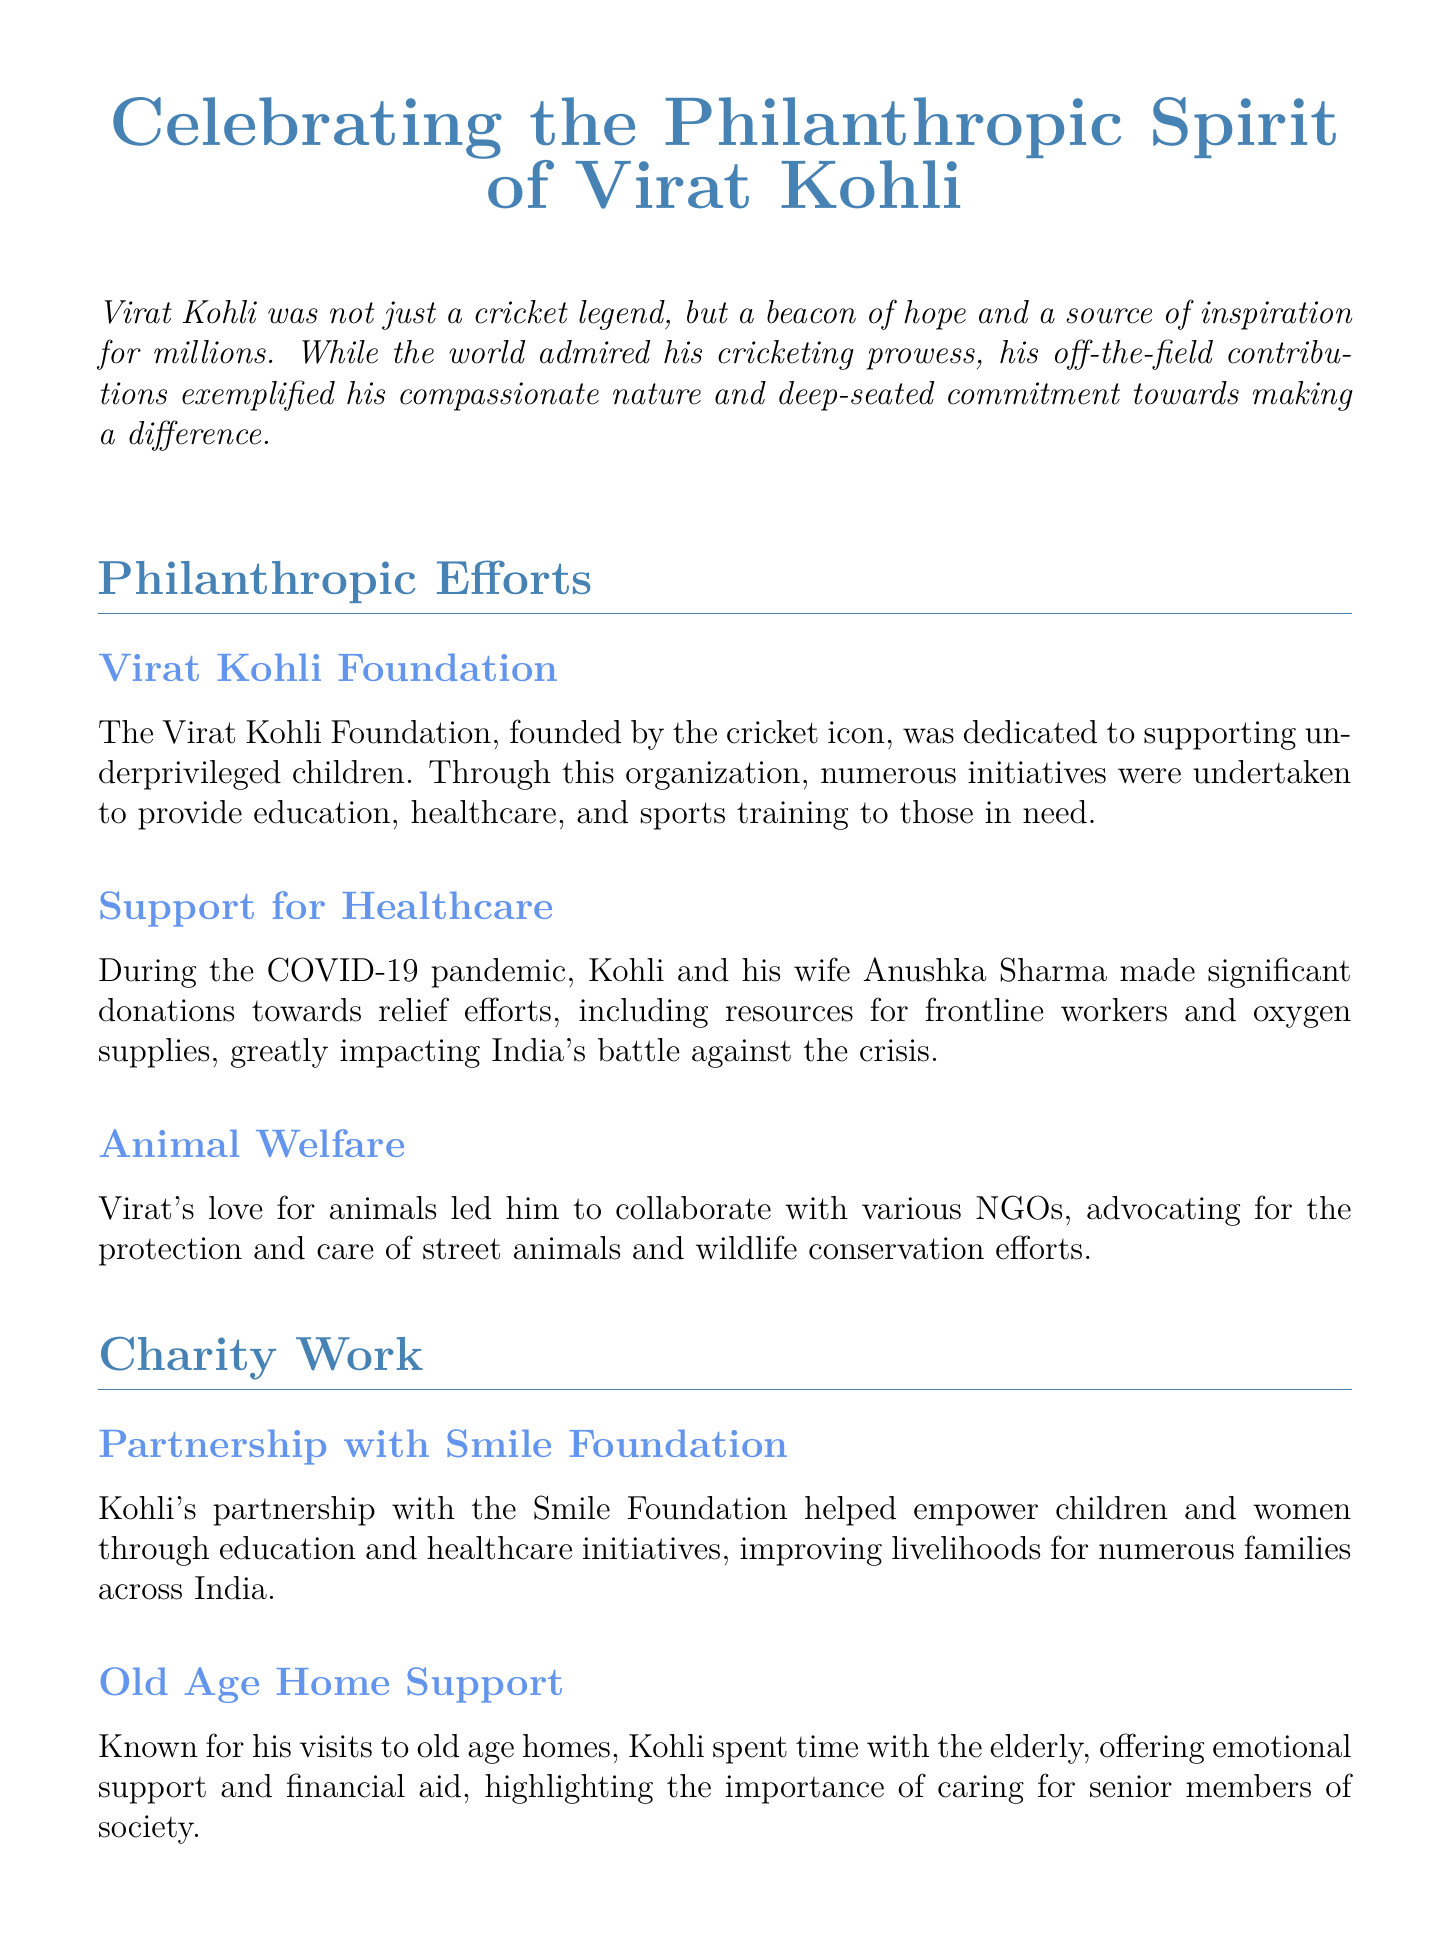What is the name of Virat Kohli's foundation? The document mentions the Virat Kohli Foundation as his philanthropic initiative.
Answer: Virat Kohli Foundation What type of support did Kohli and Anushka provide during the COVID-19 pandemic? They made significant donations towards relief efforts, including resources for frontline workers and oxygen supplies.
Answer: Relief efforts Which foundation did Kohli partner with for education and healthcare initiatives? Kohli's partnership with the Smile Foundation focused on empowering children and women.
Answer: Smile Foundation What is one of the key causes Kohli advocates for besides sports? Kohli promotes mental health awareness and destigmatization of mental health issues.
Answer: Mental health What demographic did Kohli specifically visit to offer support within old age homes? The document states Kohli spent time with the elderly, highlighting the importance of caring for senior members of society.
Answer: Elderly 